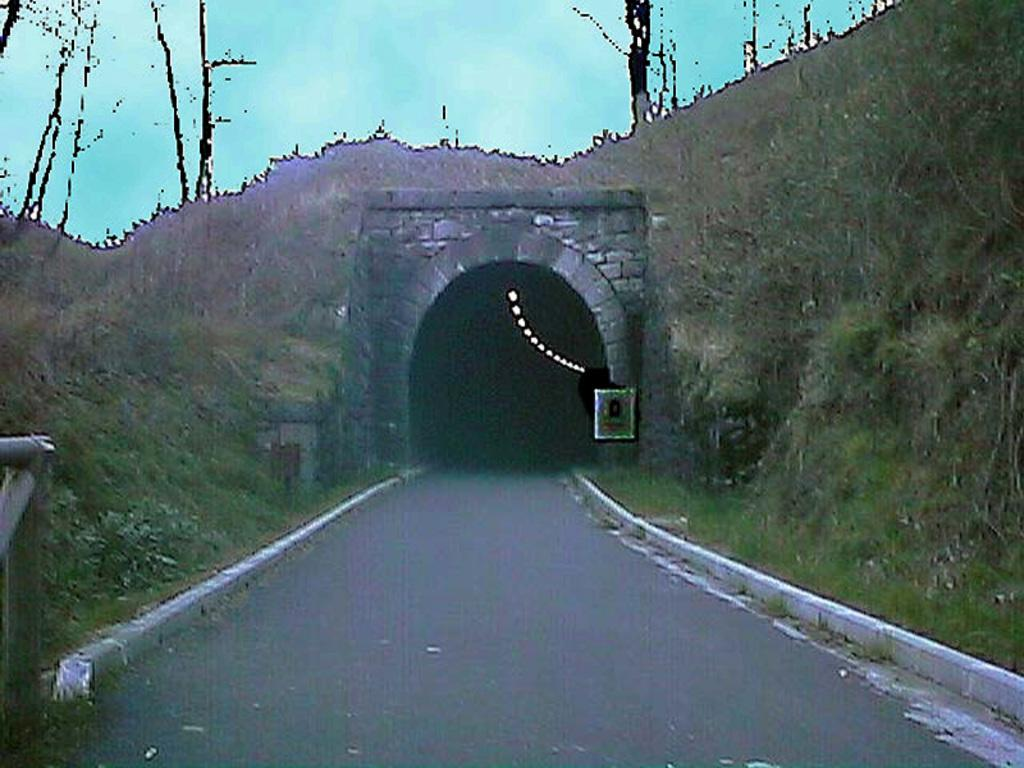What type of pathway is visible in the image? There is a road in the image. What structure can be seen along the road? There is a tunnel in the image. What feature is present on the tunnel roof? Lights are present on the tunnel roof. What type of vegetation is visible on the ground? Grass is visible on the ground. What can be seen in the sky in the image? Clouds are present in the sky. What object is located on the left side of the image? There is a metal object on the left side of the image. What type of spark can be seen coming from the tunnel in the image? There is no spark present in the image; the tunnel has lights on its roof. What type of needle is used to sew the clouds in the image? There is no needle present in the image; the clouds are natural formations in the sky. 